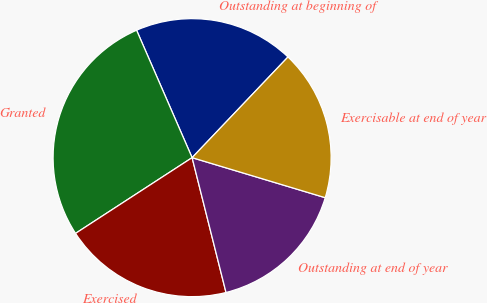<chart> <loc_0><loc_0><loc_500><loc_500><pie_chart><fcel>Outstanding at beginning of<fcel>Granted<fcel>Exercised<fcel>Outstanding at end of year<fcel>Exercisable at end of year<nl><fcel>18.65%<fcel>27.63%<fcel>19.75%<fcel>16.43%<fcel>17.54%<nl></chart> 